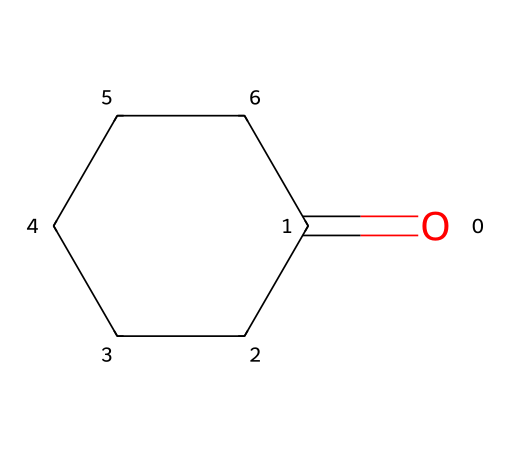What is the molecular formula of cyclohexanone? By analyzing the structure represented in the SMILES, O=C1CCCCC1, we identify that there are six carbon atoms (C) from the cyclohexane ring and one oxygen atom (O) from the carbonyl group (C=O), leading to the molecular formula C6H10O.
Answer: C6H10O How many carbon atoms are in cyclohexanone? The structure shows that there are six vertices corresponding to carbon atoms in the cyclohexane ring, thus the number of carbon atoms is six.
Answer: 6 What type of functional group is present in cyclohexanone? The presence of the carbonyl group (C=O) indicates that cyclohexanone belongs to the ketone functional group family, as it is characterized by the carbonyl group between carbon atoms.
Answer: ketone How many hydrogen atoms are in cyclohexanone? The calculated molecular formula C6H10O indicates there are ten hydrogen atoms associated with the carbon framework and the carbonyl group, consistent with the structure of cyclohexanone.
Answer: 10 What makes cyclohexanone suitable for nylon production? Cyclohexanone has a carbonyl functional group that can react with amines to form nylon, making it a suitable precursor in the nylon synthesis process due to its reactivity and structure.
Answer: reactivity What is the ring structure of cyclohexanone? The notation "C1CCCCC1" in the SMILES indicates a cyclic structure formed by six carbon atoms, making it a six-membered ring with one carbonyl group distinctly identified.
Answer: six-membered ring What is the degree of saturation for cyclohexanone? Examining the structure of cyclohexanone, its ring and carbonyl group contribute to a saturation level that can be calculated, indicating that it is saturated with respect to single bonds but contains a carbonyl functional group.
Answer: 1 double bond 